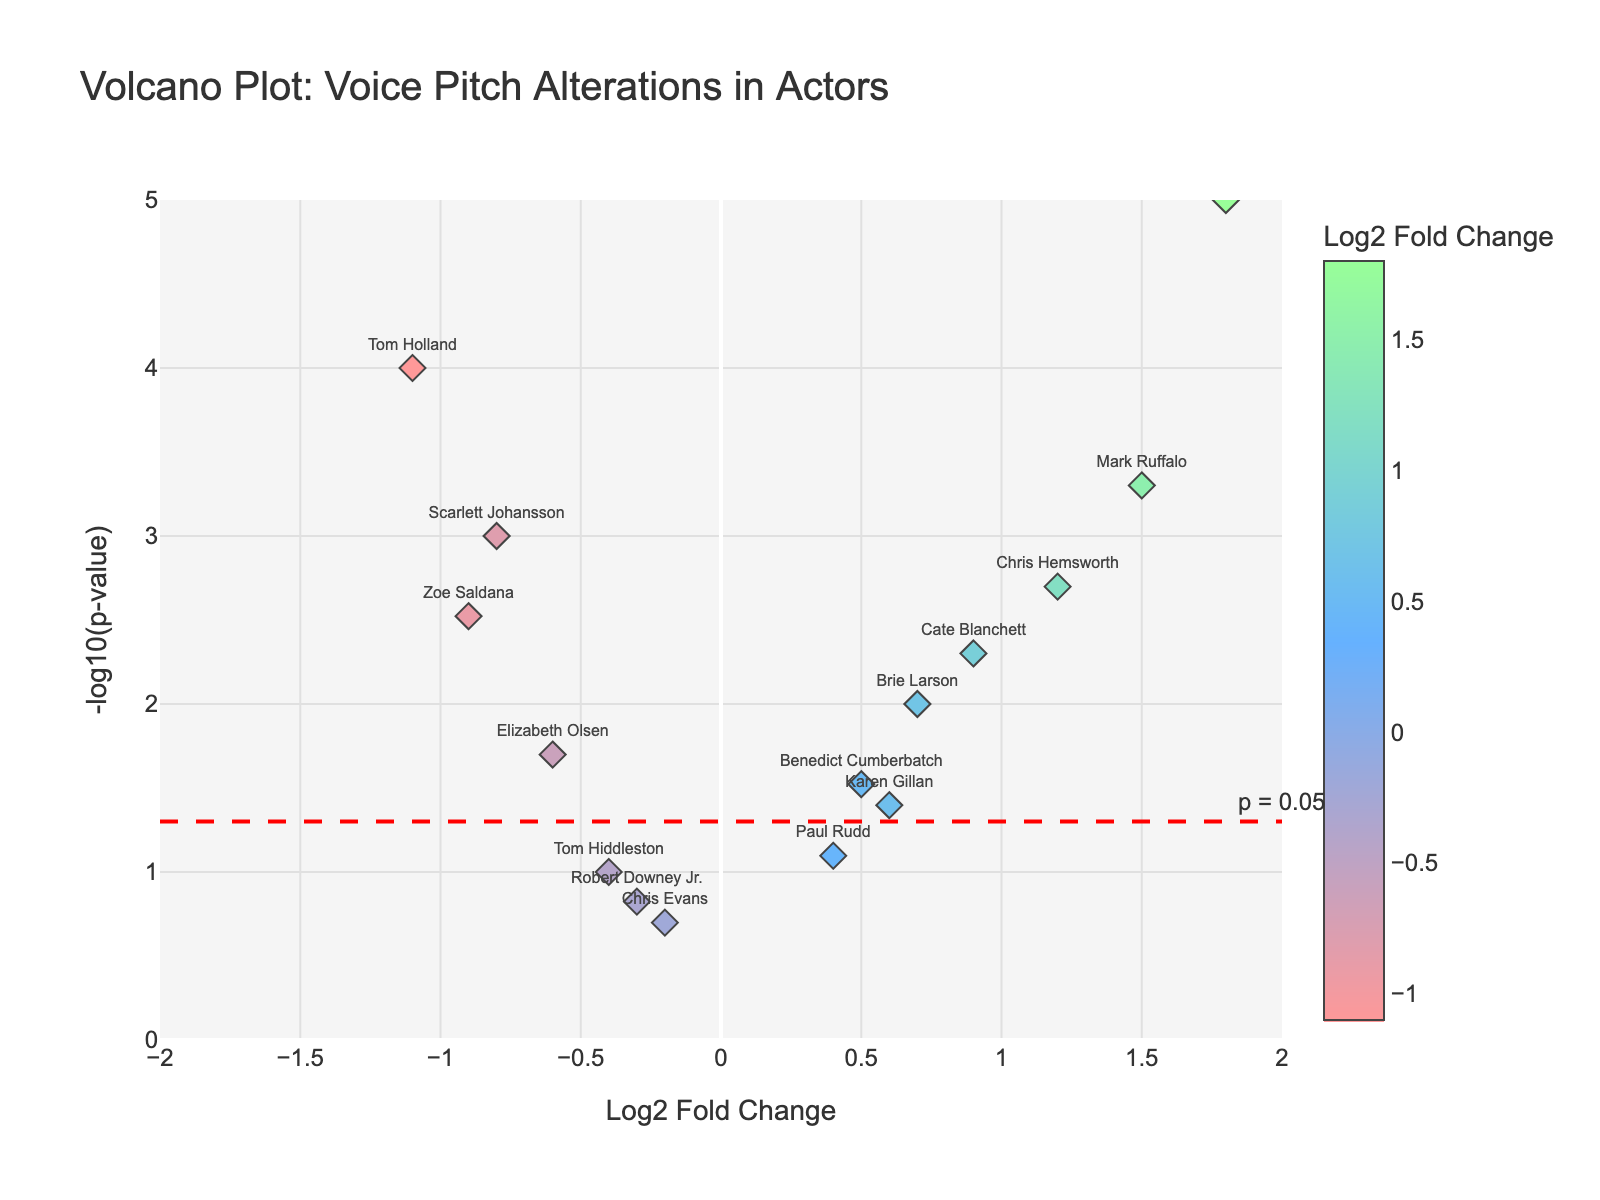What is the title of the plot? The plot's title is displayed prominently at the top of the figure. It provides an overview of the data being visualized.
Answer: Volcano Plot: Voice Pitch Alterations in Actors What is the x-axis representing in the plot? The x-axis is labeled 'Log2 Fold Change', indicating it represents the logarithmic fold change in voice pitch alterations. It ranges from -2 to 2.
Answer: Log2 Fold Change How is significance indicated in the plot? Significance is indicated by a horizontal red dashed line at -log10(p-value) = 1.3, corresponding to p = 0.05. Any points above this line are considered significant.
Answer: Horizontal red dashed line Which actor experienced the largest positive voice pitch alteration? The actor located at the far right on the x-axis has the largest positive log2 fold change. Based on the labels, this actor is Josh Brolin.
Answer: Josh Brolin How many actors display significant changes in their voice pitch? Significant changes are determined by points above the red dashed line (p = 0.05). Count the number of points above this line.
Answer: Eight actors Who had the most significant decrease in voice pitch? The actor at the lowest x-value with a significant p-value (above the red dashed line) experienced the most significant decrease. This actor is Tom Holland.
Answer: Tom Holland Compare the voice pitch alterations of Mark Ruffalo and Scarlett Johansson. Mark Ruffalo has a positive log2 fold change, while Scarlett Johansson has a negative one. Mark Ruffalo's change (1.5) is larger compared to Scarlett Johansson's (-0.8), and both are statistically significant since they are above the red dashed line.
Answer: Mark Ruffalo had a larger increase Which actor had a p-value closest to 0.03? Find the point near -log10(0.03). The closest actor to this value appears to be Benedict Cumberbatch.
Answer: Benedict Cumberbatch Which actors have non-significant voice pitch alterations? Non-significant alterations are indicated by points below the red dashed line. By visual inspection, these actors include Robert Downey Jr., Chris Evans, Paul Rudd, and Tom Hiddleston.
Answer: Robert Downey Jr., Chris Evans, Paul Rudd, and Tom Hiddleston What's the range of the y-axis in the volcano plot? The y-axis label is '-log10(p-value)', and it ranges from 0 to 5.
Answer: 0 to 5 